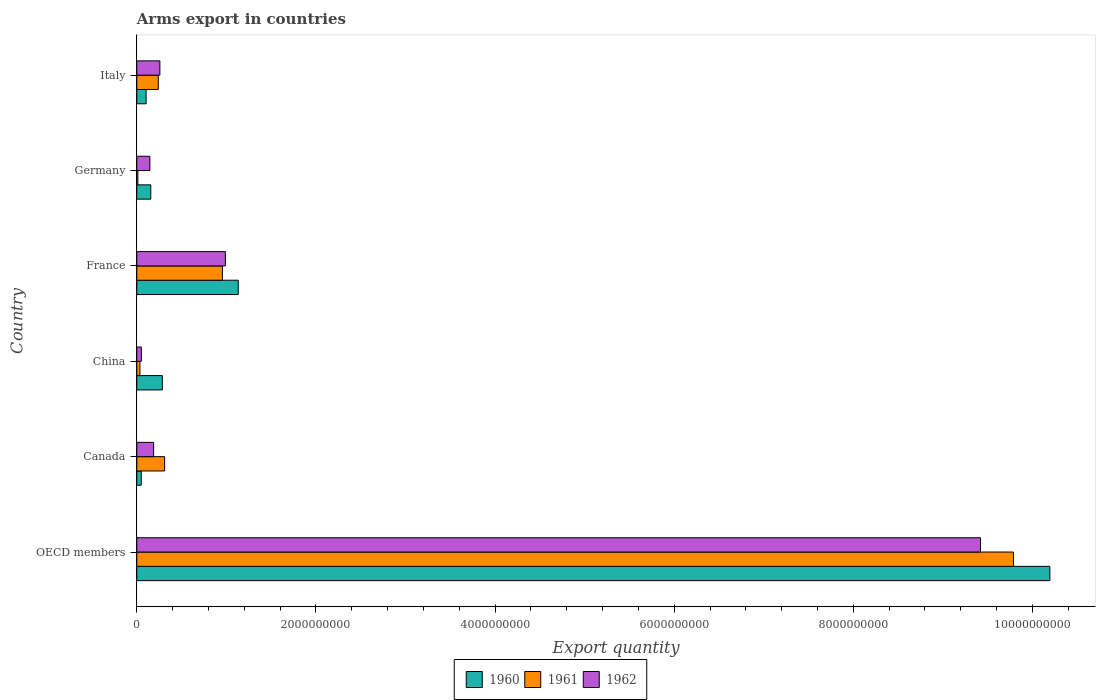How many groups of bars are there?
Ensure brevity in your answer.  6. Are the number of bars per tick equal to the number of legend labels?
Offer a very short reply. Yes. Are the number of bars on each tick of the Y-axis equal?
Provide a succinct answer. Yes. How many bars are there on the 1st tick from the top?
Provide a succinct answer. 3. How many bars are there on the 5th tick from the bottom?
Your answer should be very brief. 3. In how many cases, is the number of bars for a given country not equal to the number of legend labels?
Make the answer very short. 0. What is the total arms export in 1962 in Canada?
Provide a succinct answer. 1.88e+08. Across all countries, what is the maximum total arms export in 1962?
Give a very brief answer. 9.42e+09. Across all countries, what is the minimum total arms export in 1962?
Provide a short and direct response. 5.10e+07. What is the total total arms export in 1962 in the graph?
Offer a very short reply. 1.11e+1. What is the difference between the total arms export in 1962 in Canada and that in Germany?
Make the answer very short. 4.20e+07. What is the difference between the total arms export in 1961 in China and the total arms export in 1960 in Canada?
Your answer should be compact. -1.50e+07. What is the average total arms export in 1960 per country?
Offer a very short reply. 1.99e+09. What is the difference between the total arms export in 1962 and total arms export in 1961 in OECD members?
Ensure brevity in your answer.  -3.68e+08. In how many countries, is the total arms export in 1962 greater than 2800000000 ?
Your answer should be very brief. 1. What is the ratio of the total arms export in 1960 in France to that in Italy?
Keep it short and to the point. 10.89. Is the difference between the total arms export in 1962 in Germany and Italy greater than the difference between the total arms export in 1961 in Germany and Italy?
Make the answer very short. Yes. What is the difference between the highest and the second highest total arms export in 1961?
Your response must be concise. 8.83e+09. What is the difference between the highest and the lowest total arms export in 1961?
Your response must be concise. 9.78e+09. In how many countries, is the total arms export in 1962 greater than the average total arms export in 1962 taken over all countries?
Give a very brief answer. 1. What does the 1st bar from the top in Italy represents?
Offer a very short reply. 1962. How many countries are there in the graph?
Provide a short and direct response. 6. What is the difference between two consecutive major ticks on the X-axis?
Offer a very short reply. 2.00e+09. Does the graph contain any zero values?
Ensure brevity in your answer.  No. Does the graph contain grids?
Offer a terse response. No. Where does the legend appear in the graph?
Your answer should be very brief. Bottom center. How many legend labels are there?
Your answer should be very brief. 3. How are the legend labels stacked?
Keep it short and to the point. Horizontal. What is the title of the graph?
Give a very brief answer. Arms export in countries. What is the label or title of the X-axis?
Give a very brief answer. Export quantity. What is the Export quantity of 1960 in OECD members?
Offer a terse response. 1.02e+1. What is the Export quantity in 1961 in OECD members?
Provide a short and direct response. 9.79e+09. What is the Export quantity of 1962 in OECD members?
Provide a short and direct response. 9.42e+09. What is the Export quantity in 1961 in Canada?
Keep it short and to the point. 3.11e+08. What is the Export quantity of 1962 in Canada?
Your answer should be compact. 1.88e+08. What is the Export quantity of 1960 in China?
Your response must be concise. 2.85e+08. What is the Export quantity in 1961 in China?
Offer a terse response. 3.50e+07. What is the Export quantity in 1962 in China?
Offer a terse response. 5.10e+07. What is the Export quantity in 1960 in France?
Make the answer very short. 1.13e+09. What is the Export quantity of 1961 in France?
Your answer should be compact. 9.56e+08. What is the Export quantity of 1962 in France?
Give a very brief answer. 9.89e+08. What is the Export quantity in 1960 in Germany?
Keep it short and to the point. 1.56e+08. What is the Export quantity in 1962 in Germany?
Keep it short and to the point. 1.46e+08. What is the Export quantity in 1960 in Italy?
Provide a short and direct response. 1.04e+08. What is the Export quantity in 1961 in Italy?
Your answer should be compact. 2.40e+08. What is the Export quantity in 1962 in Italy?
Your response must be concise. 2.58e+08. Across all countries, what is the maximum Export quantity of 1960?
Offer a terse response. 1.02e+1. Across all countries, what is the maximum Export quantity in 1961?
Your response must be concise. 9.79e+09. Across all countries, what is the maximum Export quantity of 1962?
Ensure brevity in your answer.  9.42e+09. Across all countries, what is the minimum Export quantity of 1962?
Your answer should be compact. 5.10e+07. What is the total Export quantity in 1960 in the graph?
Offer a very short reply. 1.19e+1. What is the total Export quantity in 1961 in the graph?
Ensure brevity in your answer.  1.13e+1. What is the total Export quantity of 1962 in the graph?
Make the answer very short. 1.11e+1. What is the difference between the Export quantity in 1960 in OECD members and that in Canada?
Offer a terse response. 1.01e+1. What is the difference between the Export quantity in 1961 in OECD members and that in Canada?
Your answer should be compact. 9.48e+09. What is the difference between the Export quantity of 1962 in OECD members and that in Canada?
Ensure brevity in your answer.  9.23e+09. What is the difference between the Export quantity of 1960 in OECD members and that in China?
Keep it short and to the point. 9.91e+09. What is the difference between the Export quantity in 1961 in OECD members and that in China?
Ensure brevity in your answer.  9.75e+09. What is the difference between the Export quantity in 1962 in OECD members and that in China?
Keep it short and to the point. 9.37e+09. What is the difference between the Export quantity in 1960 in OECD members and that in France?
Make the answer very short. 9.06e+09. What is the difference between the Export quantity of 1961 in OECD members and that in France?
Give a very brief answer. 8.83e+09. What is the difference between the Export quantity in 1962 in OECD members and that in France?
Your answer should be compact. 8.43e+09. What is the difference between the Export quantity in 1960 in OECD members and that in Germany?
Ensure brevity in your answer.  1.00e+1. What is the difference between the Export quantity of 1961 in OECD members and that in Germany?
Ensure brevity in your answer.  9.78e+09. What is the difference between the Export quantity of 1962 in OECD members and that in Germany?
Make the answer very short. 9.27e+09. What is the difference between the Export quantity in 1960 in OECD members and that in Italy?
Your answer should be very brief. 1.01e+1. What is the difference between the Export quantity of 1961 in OECD members and that in Italy?
Ensure brevity in your answer.  9.55e+09. What is the difference between the Export quantity in 1962 in OECD members and that in Italy?
Provide a succinct answer. 9.16e+09. What is the difference between the Export quantity of 1960 in Canada and that in China?
Your answer should be compact. -2.35e+08. What is the difference between the Export quantity of 1961 in Canada and that in China?
Offer a very short reply. 2.76e+08. What is the difference between the Export quantity of 1962 in Canada and that in China?
Your answer should be compact. 1.37e+08. What is the difference between the Export quantity in 1960 in Canada and that in France?
Make the answer very short. -1.08e+09. What is the difference between the Export quantity of 1961 in Canada and that in France?
Your response must be concise. -6.45e+08. What is the difference between the Export quantity of 1962 in Canada and that in France?
Provide a short and direct response. -8.01e+08. What is the difference between the Export quantity in 1960 in Canada and that in Germany?
Provide a short and direct response. -1.06e+08. What is the difference between the Export quantity of 1961 in Canada and that in Germany?
Keep it short and to the point. 2.99e+08. What is the difference between the Export quantity in 1962 in Canada and that in Germany?
Your answer should be compact. 4.20e+07. What is the difference between the Export quantity of 1960 in Canada and that in Italy?
Provide a succinct answer. -5.40e+07. What is the difference between the Export quantity of 1961 in Canada and that in Italy?
Provide a short and direct response. 7.10e+07. What is the difference between the Export quantity in 1962 in Canada and that in Italy?
Ensure brevity in your answer.  -7.00e+07. What is the difference between the Export quantity in 1960 in China and that in France?
Offer a very short reply. -8.48e+08. What is the difference between the Export quantity in 1961 in China and that in France?
Your answer should be compact. -9.21e+08. What is the difference between the Export quantity of 1962 in China and that in France?
Ensure brevity in your answer.  -9.38e+08. What is the difference between the Export quantity of 1960 in China and that in Germany?
Make the answer very short. 1.29e+08. What is the difference between the Export quantity in 1961 in China and that in Germany?
Give a very brief answer. 2.30e+07. What is the difference between the Export quantity of 1962 in China and that in Germany?
Your response must be concise. -9.50e+07. What is the difference between the Export quantity of 1960 in China and that in Italy?
Provide a succinct answer. 1.81e+08. What is the difference between the Export quantity in 1961 in China and that in Italy?
Provide a short and direct response. -2.05e+08. What is the difference between the Export quantity in 1962 in China and that in Italy?
Provide a succinct answer. -2.07e+08. What is the difference between the Export quantity of 1960 in France and that in Germany?
Give a very brief answer. 9.77e+08. What is the difference between the Export quantity in 1961 in France and that in Germany?
Offer a very short reply. 9.44e+08. What is the difference between the Export quantity in 1962 in France and that in Germany?
Offer a very short reply. 8.43e+08. What is the difference between the Export quantity of 1960 in France and that in Italy?
Your answer should be compact. 1.03e+09. What is the difference between the Export quantity in 1961 in France and that in Italy?
Give a very brief answer. 7.16e+08. What is the difference between the Export quantity of 1962 in France and that in Italy?
Provide a succinct answer. 7.31e+08. What is the difference between the Export quantity of 1960 in Germany and that in Italy?
Provide a short and direct response. 5.20e+07. What is the difference between the Export quantity of 1961 in Germany and that in Italy?
Your answer should be compact. -2.28e+08. What is the difference between the Export quantity in 1962 in Germany and that in Italy?
Your answer should be compact. -1.12e+08. What is the difference between the Export quantity in 1960 in OECD members and the Export quantity in 1961 in Canada?
Your response must be concise. 9.88e+09. What is the difference between the Export quantity of 1960 in OECD members and the Export quantity of 1962 in Canada?
Ensure brevity in your answer.  1.00e+1. What is the difference between the Export quantity in 1961 in OECD members and the Export quantity in 1962 in Canada?
Give a very brief answer. 9.60e+09. What is the difference between the Export quantity in 1960 in OECD members and the Export quantity in 1961 in China?
Make the answer very short. 1.02e+1. What is the difference between the Export quantity of 1960 in OECD members and the Export quantity of 1962 in China?
Keep it short and to the point. 1.01e+1. What is the difference between the Export quantity of 1961 in OECD members and the Export quantity of 1962 in China?
Provide a succinct answer. 9.74e+09. What is the difference between the Export quantity of 1960 in OECD members and the Export quantity of 1961 in France?
Offer a terse response. 9.24e+09. What is the difference between the Export quantity in 1960 in OECD members and the Export quantity in 1962 in France?
Your answer should be compact. 9.20e+09. What is the difference between the Export quantity in 1961 in OECD members and the Export quantity in 1962 in France?
Offer a very short reply. 8.80e+09. What is the difference between the Export quantity in 1960 in OECD members and the Export quantity in 1961 in Germany?
Your answer should be compact. 1.02e+1. What is the difference between the Export quantity of 1960 in OECD members and the Export quantity of 1962 in Germany?
Ensure brevity in your answer.  1.00e+1. What is the difference between the Export quantity in 1961 in OECD members and the Export quantity in 1962 in Germany?
Keep it short and to the point. 9.64e+09. What is the difference between the Export quantity of 1960 in OECD members and the Export quantity of 1961 in Italy?
Offer a very short reply. 9.95e+09. What is the difference between the Export quantity in 1960 in OECD members and the Export quantity in 1962 in Italy?
Provide a short and direct response. 9.94e+09. What is the difference between the Export quantity of 1961 in OECD members and the Export quantity of 1962 in Italy?
Your answer should be compact. 9.53e+09. What is the difference between the Export quantity of 1960 in Canada and the Export quantity of 1961 in China?
Ensure brevity in your answer.  1.50e+07. What is the difference between the Export quantity in 1960 in Canada and the Export quantity in 1962 in China?
Offer a terse response. -1.00e+06. What is the difference between the Export quantity in 1961 in Canada and the Export quantity in 1962 in China?
Offer a very short reply. 2.60e+08. What is the difference between the Export quantity of 1960 in Canada and the Export quantity of 1961 in France?
Your answer should be compact. -9.06e+08. What is the difference between the Export quantity in 1960 in Canada and the Export quantity in 1962 in France?
Provide a succinct answer. -9.39e+08. What is the difference between the Export quantity in 1961 in Canada and the Export quantity in 1962 in France?
Ensure brevity in your answer.  -6.78e+08. What is the difference between the Export quantity of 1960 in Canada and the Export quantity of 1961 in Germany?
Ensure brevity in your answer.  3.80e+07. What is the difference between the Export quantity of 1960 in Canada and the Export quantity of 1962 in Germany?
Ensure brevity in your answer.  -9.60e+07. What is the difference between the Export quantity in 1961 in Canada and the Export quantity in 1962 in Germany?
Give a very brief answer. 1.65e+08. What is the difference between the Export quantity of 1960 in Canada and the Export quantity of 1961 in Italy?
Offer a very short reply. -1.90e+08. What is the difference between the Export quantity in 1960 in Canada and the Export quantity in 1962 in Italy?
Provide a short and direct response. -2.08e+08. What is the difference between the Export quantity of 1961 in Canada and the Export quantity of 1962 in Italy?
Offer a terse response. 5.30e+07. What is the difference between the Export quantity in 1960 in China and the Export quantity in 1961 in France?
Make the answer very short. -6.71e+08. What is the difference between the Export quantity in 1960 in China and the Export quantity in 1962 in France?
Your answer should be very brief. -7.04e+08. What is the difference between the Export quantity of 1961 in China and the Export quantity of 1962 in France?
Give a very brief answer. -9.54e+08. What is the difference between the Export quantity of 1960 in China and the Export quantity of 1961 in Germany?
Your answer should be compact. 2.73e+08. What is the difference between the Export quantity in 1960 in China and the Export quantity in 1962 in Germany?
Ensure brevity in your answer.  1.39e+08. What is the difference between the Export quantity in 1961 in China and the Export quantity in 1962 in Germany?
Provide a short and direct response. -1.11e+08. What is the difference between the Export quantity in 1960 in China and the Export quantity in 1961 in Italy?
Give a very brief answer. 4.50e+07. What is the difference between the Export quantity in 1960 in China and the Export quantity in 1962 in Italy?
Offer a very short reply. 2.70e+07. What is the difference between the Export quantity in 1961 in China and the Export quantity in 1962 in Italy?
Offer a very short reply. -2.23e+08. What is the difference between the Export quantity of 1960 in France and the Export quantity of 1961 in Germany?
Your answer should be very brief. 1.12e+09. What is the difference between the Export quantity of 1960 in France and the Export quantity of 1962 in Germany?
Offer a very short reply. 9.87e+08. What is the difference between the Export quantity of 1961 in France and the Export quantity of 1962 in Germany?
Ensure brevity in your answer.  8.10e+08. What is the difference between the Export quantity in 1960 in France and the Export quantity in 1961 in Italy?
Give a very brief answer. 8.93e+08. What is the difference between the Export quantity in 1960 in France and the Export quantity in 1962 in Italy?
Provide a short and direct response. 8.75e+08. What is the difference between the Export quantity in 1961 in France and the Export quantity in 1962 in Italy?
Your answer should be very brief. 6.98e+08. What is the difference between the Export quantity in 1960 in Germany and the Export quantity in 1961 in Italy?
Your answer should be very brief. -8.40e+07. What is the difference between the Export quantity in 1960 in Germany and the Export quantity in 1962 in Italy?
Provide a succinct answer. -1.02e+08. What is the difference between the Export quantity of 1961 in Germany and the Export quantity of 1962 in Italy?
Make the answer very short. -2.46e+08. What is the average Export quantity of 1960 per country?
Offer a very short reply. 1.99e+09. What is the average Export quantity of 1961 per country?
Keep it short and to the point. 1.89e+09. What is the average Export quantity of 1962 per country?
Offer a terse response. 1.84e+09. What is the difference between the Export quantity of 1960 and Export quantity of 1961 in OECD members?
Offer a very short reply. 4.06e+08. What is the difference between the Export quantity of 1960 and Export quantity of 1962 in OECD members?
Provide a succinct answer. 7.74e+08. What is the difference between the Export quantity of 1961 and Export quantity of 1962 in OECD members?
Offer a terse response. 3.68e+08. What is the difference between the Export quantity of 1960 and Export quantity of 1961 in Canada?
Keep it short and to the point. -2.61e+08. What is the difference between the Export quantity of 1960 and Export quantity of 1962 in Canada?
Ensure brevity in your answer.  -1.38e+08. What is the difference between the Export quantity of 1961 and Export quantity of 1962 in Canada?
Your response must be concise. 1.23e+08. What is the difference between the Export quantity in 1960 and Export quantity in 1961 in China?
Your answer should be compact. 2.50e+08. What is the difference between the Export quantity in 1960 and Export quantity in 1962 in China?
Your answer should be compact. 2.34e+08. What is the difference between the Export quantity in 1961 and Export quantity in 1962 in China?
Offer a terse response. -1.60e+07. What is the difference between the Export quantity of 1960 and Export quantity of 1961 in France?
Give a very brief answer. 1.77e+08. What is the difference between the Export quantity in 1960 and Export quantity in 1962 in France?
Keep it short and to the point. 1.44e+08. What is the difference between the Export quantity of 1961 and Export quantity of 1962 in France?
Your response must be concise. -3.30e+07. What is the difference between the Export quantity in 1960 and Export quantity in 1961 in Germany?
Make the answer very short. 1.44e+08. What is the difference between the Export quantity of 1960 and Export quantity of 1962 in Germany?
Give a very brief answer. 1.00e+07. What is the difference between the Export quantity of 1961 and Export quantity of 1962 in Germany?
Offer a terse response. -1.34e+08. What is the difference between the Export quantity of 1960 and Export quantity of 1961 in Italy?
Ensure brevity in your answer.  -1.36e+08. What is the difference between the Export quantity in 1960 and Export quantity in 1962 in Italy?
Your answer should be compact. -1.54e+08. What is the difference between the Export quantity in 1961 and Export quantity in 1962 in Italy?
Offer a terse response. -1.80e+07. What is the ratio of the Export quantity in 1960 in OECD members to that in Canada?
Your answer should be compact. 203.88. What is the ratio of the Export quantity in 1961 in OECD members to that in Canada?
Your answer should be very brief. 31.47. What is the ratio of the Export quantity of 1962 in OECD members to that in Canada?
Offer a very short reply. 50.11. What is the ratio of the Export quantity of 1960 in OECD members to that in China?
Provide a short and direct response. 35.77. What is the ratio of the Export quantity in 1961 in OECD members to that in China?
Your answer should be compact. 279.66. What is the ratio of the Export quantity of 1962 in OECD members to that in China?
Ensure brevity in your answer.  184.71. What is the ratio of the Export quantity of 1960 in OECD members to that in France?
Your answer should be very brief. 9. What is the ratio of the Export quantity of 1961 in OECD members to that in France?
Give a very brief answer. 10.24. What is the ratio of the Export quantity of 1962 in OECD members to that in France?
Your answer should be compact. 9.52. What is the ratio of the Export quantity of 1960 in OECD members to that in Germany?
Make the answer very short. 65.35. What is the ratio of the Export quantity in 1961 in OECD members to that in Germany?
Ensure brevity in your answer.  815.67. What is the ratio of the Export quantity of 1962 in OECD members to that in Germany?
Provide a succinct answer. 64.52. What is the ratio of the Export quantity in 1960 in OECD members to that in Italy?
Offer a very short reply. 98.02. What is the ratio of the Export quantity of 1961 in OECD members to that in Italy?
Your response must be concise. 40.78. What is the ratio of the Export quantity in 1962 in OECD members to that in Italy?
Your response must be concise. 36.51. What is the ratio of the Export quantity in 1960 in Canada to that in China?
Give a very brief answer. 0.18. What is the ratio of the Export quantity in 1961 in Canada to that in China?
Your answer should be very brief. 8.89. What is the ratio of the Export quantity of 1962 in Canada to that in China?
Keep it short and to the point. 3.69. What is the ratio of the Export quantity in 1960 in Canada to that in France?
Keep it short and to the point. 0.04. What is the ratio of the Export quantity in 1961 in Canada to that in France?
Offer a very short reply. 0.33. What is the ratio of the Export quantity in 1962 in Canada to that in France?
Offer a very short reply. 0.19. What is the ratio of the Export quantity in 1960 in Canada to that in Germany?
Provide a succinct answer. 0.32. What is the ratio of the Export quantity of 1961 in Canada to that in Germany?
Keep it short and to the point. 25.92. What is the ratio of the Export quantity in 1962 in Canada to that in Germany?
Offer a terse response. 1.29. What is the ratio of the Export quantity of 1960 in Canada to that in Italy?
Offer a terse response. 0.48. What is the ratio of the Export quantity in 1961 in Canada to that in Italy?
Offer a very short reply. 1.3. What is the ratio of the Export quantity in 1962 in Canada to that in Italy?
Your answer should be very brief. 0.73. What is the ratio of the Export quantity of 1960 in China to that in France?
Offer a very short reply. 0.25. What is the ratio of the Export quantity in 1961 in China to that in France?
Provide a succinct answer. 0.04. What is the ratio of the Export quantity of 1962 in China to that in France?
Keep it short and to the point. 0.05. What is the ratio of the Export quantity of 1960 in China to that in Germany?
Provide a short and direct response. 1.83. What is the ratio of the Export quantity of 1961 in China to that in Germany?
Give a very brief answer. 2.92. What is the ratio of the Export quantity of 1962 in China to that in Germany?
Offer a terse response. 0.35. What is the ratio of the Export quantity of 1960 in China to that in Italy?
Provide a succinct answer. 2.74. What is the ratio of the Export quantity of 1961 in China to that in Italy?
Make the answer very short. 0.15. What is the ratio of the Export quantity of 1962 in China to that in Italy?
Give a very brief answer. 0.2. What is the ratio of the Export quantity of 1960 in France to that in Germany?
Provide a succinct answer. 7.26. What is the ratio of the Export quantity of 1961 in France to that in Germany?
Provide a short and direct response. 79.67. What is the ratio of the Export quantity of 1962 in France to that in Germany?
Provide a succinct answer. 6.77. What is the ratio of the Export quantity of 1960 in France to that in Italy?
Give a very brief answer. 10.89. What is the ratio of the Export quantity in 1961 in France to that in Italy?
Your answer should be very brief. 3.98. What is the ratio of the Export quantity in 1962 in France to that in Italy?
Ensure brevity in your answer.  3.83. What is the ratio of the Export quantity in 1960 in Germany to that in Italy?
Keep it short and to the point. 1.5. What is the ratio of the Export quantity of 1962 in Germany to that in Italy?
Provide a succinct answer. 0.57. What is the difference between the highest and the second highest Export quantity in 1960?
Keep it short and to the point. 9.06e+09. What is the difference between the highest and the second highest Export quantity in 1961?
Offer a very short reply. 8.83e+09. What is the difference between the highest and the second highest Export quantity of 1962?
Ensure brevity in your answer.  8.43e+09. What is the difference between the highest and the lowest Export quantity in 1960?
Your response must be concise. 1.01e+1. What is the difference between the highest and the lowest Export quantity of 1961?
Keep it short and to the point. 9.78e+09. What is the difference between the highest and the lowest Export quantity in 1962?
Your response must be concise. 9.37e+09. 